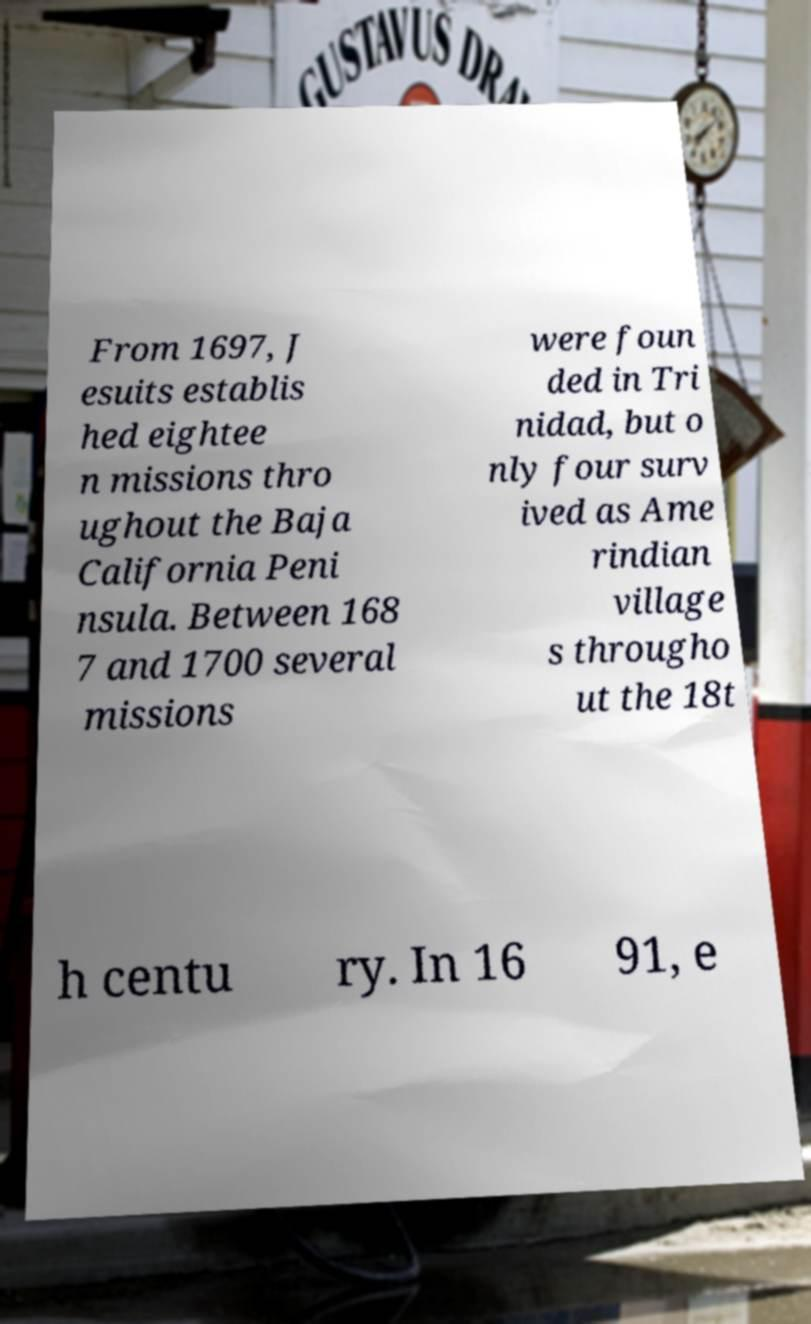There's text embedded in this image that I need extracted. Can you transcribe it verbatim? From 1697, J esuits establis hed eightee n missions thro ughout the Baja California Peni nsula. Between 168 7 and 1700 several missions were foun ded in Tri nidad, but o nly four surv ived as Ame rindian village s througho ut the 18t h centu ry. In 16 91, e 